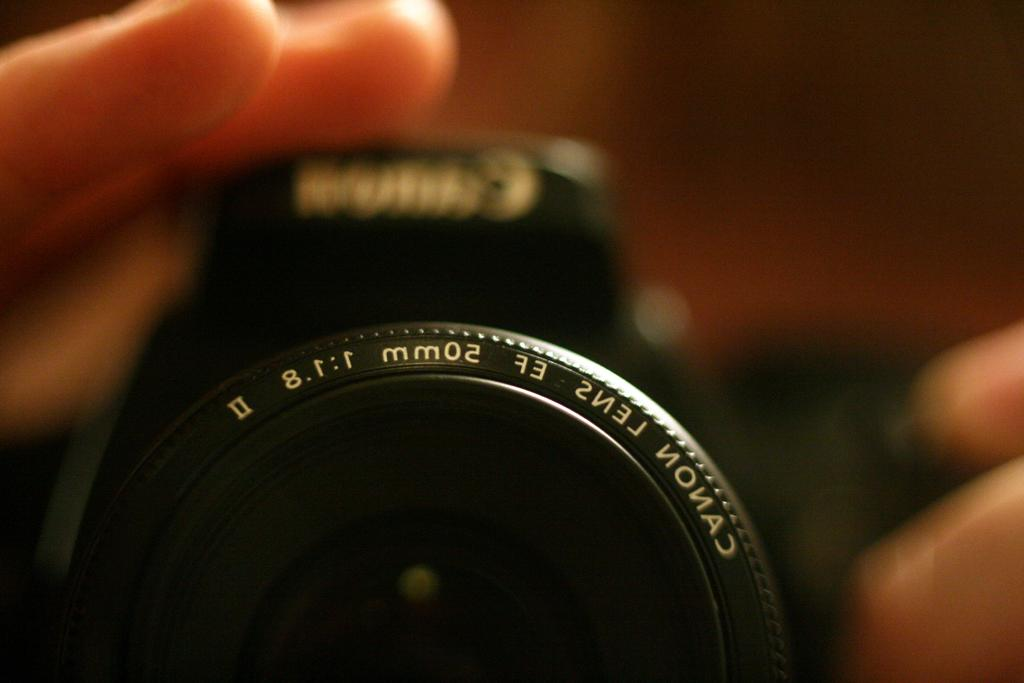What object is the main focus of the image? There is a camera lens in the image. Who or what is holding the camera lens? A hand is holding the camera. What can be observed about the background of the image? The background of the image is blurry. What type of thought is being expressed by the camera lens in the image? There is no indication of any thoughts being expressed by the camera lens, as it is an inanimate object. 